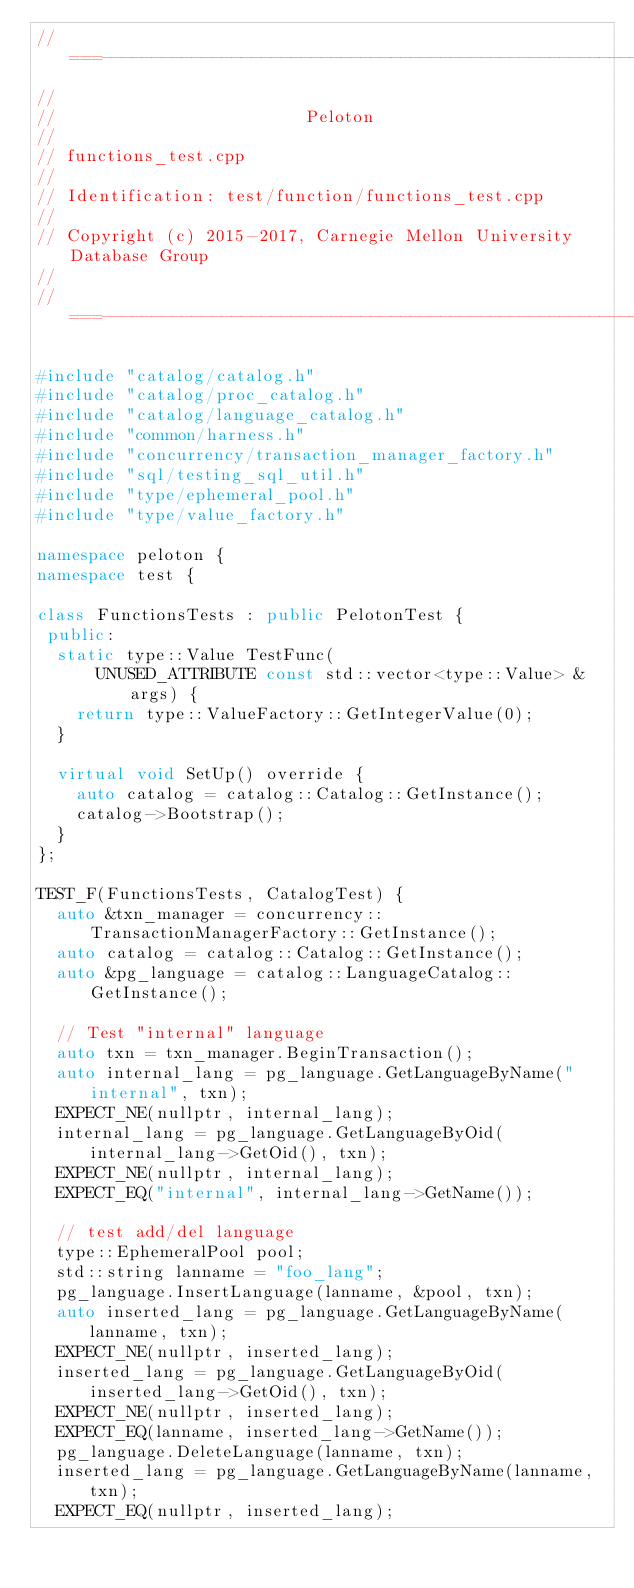<code> <loc_0><loc_0><loc_500><loc_500><_C++_>//===----------------------------------------------------------------------===//
//
//                         Peloton
//
// functions_test.cpp
//
// Identification: test/function/functions_test.cpp
//
// Copyright (c) 2015-2017, Carnegie Mellon University Database Group
//
//===----------------------------------------------------------------------===//

#include "catalog/catalog.h"
#include "catalog/proc_catalog.h"
#include "catalog/language_catalog.h"
#include "common/harness.h"
#include "concurrency/transaction_manager_factory.h"
#include "sql/testing_sql_util.h"
#include "type/ephemeral_pool.h"
#include "type/value_factory.h"

namespace peloton {
namespace test {

class FunctionsTests : public PelotonTest {
 public:
  static type::Value TestFunc(
      UNUSED_ATTRIBUTE const std::vector<type::Value> &args) {
    return type::ValueFactory::GetIntegerValue(0);
  }

  virtual void SetUp() override {
    auto catalog = catalog::Catalog::GetInstance();
    catalog->Bootstrap();
  }
};

TEST_F(FunctionsTests, CatalogTest) {
  auto &txn_manager = concurrency::TransactionManagerFactory::GetInstance();
  auto catalog = catalog::Catalog::GetInstance();
  auto &pg_language = catalog::LanguageCatalog::GetInstance();

  // Test "internal" language
  auto txn = txn_manager.BeginTransaction();
  auto internal_lang = pg_language.GetLanguageByName("internal", txn);
  EXPECT_NE(nullptr, internal_lang);
  internal_lang = pg_language.GetLanguageByOid(internal_lang->GetOid(), txn);
  EXPECT_NE(nullptr, internal_lang);
  EXPECT_EQ("internal", internal_lang->GetName());

  // test add/del language
  type::EphemeralPool pool;
  std::string lanname = "foo_lang";
  pg_language.InsertLanguage(lanname, &pool, txn);
  auto inserted_lang = pg_language.GetLanguageByName(lanname, txn);
  EXPECT_NE(nullptr, inserted_lang);
  inserted_lang = pg_language.GetLanguageByOid(inserted_lang->GetOid(), txn);
  EXPECT_NE(nullptr, inserted_lang);
  EXPECT_EQ(lanname, inserted_lang->GetName());
  pg_language.DeleteLanguage(lanname, txn);
  inserted_lang = pg_language.GetLanguageByName(lanname, txn);
  EXPECT_EQ(nullptr, inserted_lang);
</code> 